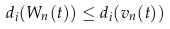Convert formula to latex. <formula><loc_0><loc_0><loc_500><loc_500>d _ { i } ( W _ { n } ( t ) ) \leq d _ { i } ( v _ { n } ( t ) )</formula> 